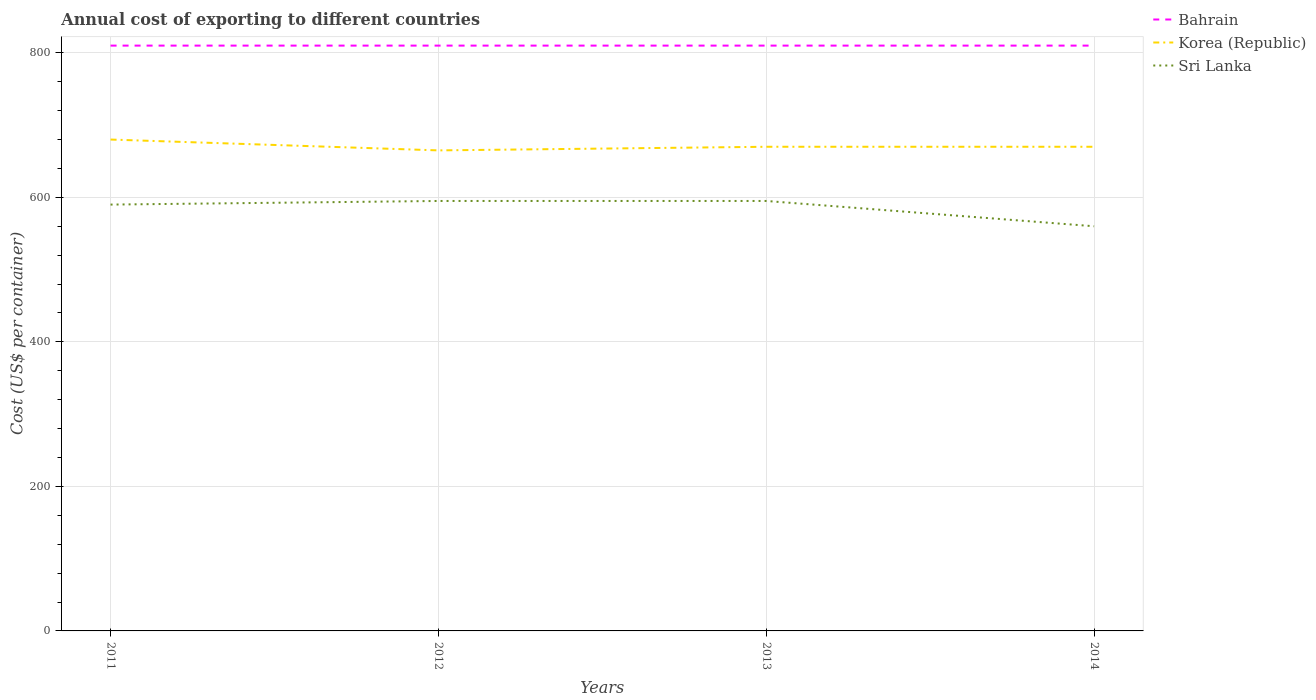Does the line corresponding to Bahrain intersect with the line corresponding to Sri Lanka?
Provide a short and direct response. No. Is the number of lines equal to the number of legend labels?
Offer a very short reply. Yes. Across all years, what is the maximum total annual cost of exporting in Sri Lanka?
Make the answer very short. 560. What is the total total annual cost of exporting in Bahrain in the graph?
Keep it short and to the point. 0. What is the difference between the highest and the second highest total annual cost of exporting in Bahrain?
Give a very brief answer. 0. How many lines are there?
Your answer should be very brief. 3. How many years are there in the graph?
Provide a succinct answer. 4. What is the difference between two consecutive major ticks on the Y-axis?
Provide a short and direct response. 200. Are the values on the major ticks of Y-axis written in scientific E-notation?
Your answer should be compact. No. Does the graph contain any zero values?
Offer a terse response. No. Where does the legend appear in the graph?
Your answer should be very brief. Top right. How are the legend labels stacked?
Make the answer very short. Vertical. What is the title of the graph?
Provide a succinct answer. Annual cost of exporting to different countries. What is the label or title of the X-axis?
Your answer should be very brief. Years. What is the label or title of the Y-axis?
Provide a short and direct response. Cost (US$ per container). What is the Cost (US$ per container) of Bahrain in 2011?
Your answer should be compact. 810. What is the Cost (US$ per container) of Korea (Republic) in 2011?
Provide a short and direct response. 680. What is the Cost (US$ per container) of Sri Lanka in 2011?
Ensure brevity in your answer.  590. What is the Cost (US$ per container) in Bahrain in 2012?
Offer a terse response. 810. What is the Cost (US$ per container) in Korea (Republic) in 2012?
Provide a short and direct response. 665. What is the Cost (US$ per container) in Sri Lanka in 2012?
Make the answer very short. 595. What is the Cost (US$ per container) in Bahrain in 2013?
Offer a terse response. 810. What is the Cost (US$ per container) of Korea (Republic) in 2013?
Offer a terse response. 670. What is the Cost (US$ per container) in Sri Lanka in 2013?
Keep it short and to the point. 595. What is the Cost (US$ per container) in Bahrain in 2014?
Give a very brief answer. 810. What is the Cost (US$ per container) in Korea (Republic) in 2014?
Provide a succinct answer. 670. What is the Cost (US$ per container) of Sri Lanka in 2014?
Offer a terse response. 560. Across all years, what is the maximum Cost (US$ per container) of Bahrain?
Make the answer very short. 810. Across all years, what is the maximum Cost (US$ per container) in Korea (Republic)?
Make the answer very short. 680. Across all years, what is the maximum Cost (US$ per container) of Sri Lanka?
Offer a very short reply. 595. Across all years, what is the minimum Cost (US$ per container) of Bahrain?
Your response must be concise. 810. Across all years, what is the minimum Cost (US$ per container) of Korea (Republic)?
Your answer should be very brief. 665. Across all years, what is the minimum Cost (US$ per container) of Sri Lanka?
Make the answer very short. 560. What is the total Cost (US$ per container) in Bahrain in the graph?
Ensure brevity in your answer.  3240. What is the total Cost (US$ per container) in Korea (Republic) in the graph?
Offer a terse response. 2685. What is the total Cost (US$ per container) in Sri Lanka in the graph?
Give a very brief answer. 2340. What is the difference between the Cost (US$ per container) in Bahrain in 2011 and that in 2012?
Offer a very short reply. 0. What is the difference between the Cost (US$ per container) in Bahrain in 2012 and that in 2013?
Offer a very short reply. 0. What is the difference between the Cost (US$ per container) of Korea (Republic) in 2012 and that in 2013?
Your response must be concise. -5. What is the difference between the Cost (US$ per container) of Sri Lanka in 2012 and that in 2013?
Provide a succinct answer. 0. What is the difference between the Cost (US$ per container) in Bahrain in 2012 and that in 2014?
Offer a terse response. 0. What is the difference between the Cost (US$ per container) of Korea (Republic) in 2012 and that in 2014?
Offer a terse response. -5. What is the difference between the Cost (US$ per container) in Bahrain in 2013 and that in 2014?
Keep it short and to the point. 0. What is the difference between the Cost (US$ per container) in Bahrain in 2011 and the Cost (US$ per container) in Korea (Republic) in 2012?
Ensure brevity in your answer.  145. What is the difference between the Cost (US$ per container) of Bahrain in 2011 and the Cost (US$ per container) of Sri Lanka in 2012?
Give a very brief answer. 215. What is the difference between the Cost (US$ per container) in Bahrain in 2011 and the Cost (US$ per container) in Korea (Republic) in 2013?
Your answer should be compact. 140. What is the difference between the Cost (US$ per container) of Bahrain in 2011 and the Cost (US$ per container) of Sri Lanka in 2013?
Keep it short and to the point. 215. What is the difference between the Cost (US$ per container) of Korea (Republic) in 2011 and the Cost (US$ per container) of Sri Lanka in 2013?
Your response must be concise. 85. What is the difference between the Cost (US$ per container) in Bahrain in 2011 and the Cost (US$ per container) in Korea (Republic) in 2014?
Keep it short and to the point. 140. What is the difference between the Cost (US$ per container) in Bahrain in 2011 and the Cost (US$ per container) in Sri Lanka in 2014?
Your answer should be very brief. 250. What is the difference between the Cost (US$ per container) of Korea (Republic) in 2011 and the Cost (US$ per container) of Sri Lanka in 2014?
Your response must be concise. 120. What is the difference between the Cost (US$ per container) in Bahrain in 2012 and the Cost (US$ per container) in Korea (Republic) in 2013?
Keep it short and to the point. 140. What is the difference between the Cost (US$ per container) in Bahrain in 2012 and the Cost (US$ per container) in Sri Lanka in 2013?
Make the answer very short. 215. What is the difference between the Cost (US$ per container) in Bahrain in 2012 and the Cost (US$ per container) in Korea (Republic) in 2014?
Your answer should be compact. 140. What is the difference between the Cost (US$ per container) of Bahrain in 2012 and the Cost (US$ per container) of Sri Lanka in 2014?
Your response must be concise. 250. What is the difference between the Cost (US$ per container) in Korea (Republic) in 2012 and the Cost (US$ per container) in Sri Lanka in 2014?
Your response must be concise. 105. What is the difference between the Cost (US$ per container) of Bahrain in 2013 and the Cost (US$ per container) of Korea (Republic) in 2014?
Offer a very short reply. 140. What is the difference between the Cost (US$ per container) in Bahrain in 2013 and the Cost (US$ per container) in Sri Lanka in 2014?
Offer a very short reply. 250. What is the difference between the Cost (US$ per container) of Korea (Republic) in 2013 and the Cost (US$ per container) of Sri Lanka in 2014?
Keep it short and to the point. 110. What is the average Cost (US$ per container) of Bahrain per year?
Give a very brief answer. 810. What is the average Cost (US$ per container) in Korea (Republic) per year?
Your answer should be compact. 671.25. What is the average Cost (US$ per container) in Sri Lanka per year?
Ensure brevity in your answer.  585. In the year 2011, what is the difference between the Cost (US$ per container) of Bahrain and Cost (US$ per container) of Korea (Republic)?
Give a very brief answer. 130. In the year 2011, what is the difference between the Cost (US$ per container) of Bahrain and Cost (US$ per container) of Sri Lanka?
Make the answer very short. 220. In the year 2012, what is the difference between the Cost (US$ per container) in Bahrain and Cost (US$ per container) in Korea (Republic)?
Keep it short and to the point. 145. In the year 2012, what is the difference between the Cost (US$ per container) in Bahrain and Cost (US$ per container) in Sri Lanka?
Offer a very short reply. 215. In the year 2013, what is the difference between the Cost (US$ per container) in Bahrain and Cost (US$ per container) in Korea (Republic)?
Ensure brevity in your answer.  140. In the year 2013, what is the difference between the Cost (US$ per container) of Bahrain and Cost (US$ per container) of Sri Lanka?
Offer a very short reply. 215. In the year 2014, what is the difference between the Cost (US$ per container) in Bahrain and Cost (US$ per container) in Korea (Republic)?
Make the answer very short. 140. In the year 2014, what is the difference between the Cost (US$ per container) of Bahrain and Cost (US$ per container) of Sri Lanka?
Provide a succinct answer. 250. In the year 2014, what is the difference between the Cost (US$ per container) in Korea (Republic) and Cost (US$ per container) in Sri Lanka?
Your answer should be very brief. 110. What is the ratio of the Cost (US$ per container) in Bahrain in 2011 to that in 2012?
Keep it short and to the point. 1. What is the ratio of the Cost (US$ per container) in Korea (Republic) in 2011 to that in 2012?
Your answer should be very brief. 1.02. What is the ratio of the Cost (US$ per container) in Korea (Republic) in 2011 to that in 2013?
Offer a very short reply. 1.01. What is the ratio of the Cost (US$ per container) of Sri Lanka in 2011 to that in 2013?
Offer a terse response. 0.99. What is the ratio of the Cost (US$ per container) in Korea (Republic) in 2011 to that in 2014?
Your response must be concise. 1.01. What is the ratio of the Cost (US$ per container) in Sri Lanka in 2011 to that in 2014?
Keep it short and to the point. 1.05. What is the ratio of the Cost (US$ per container) of Korea (Republic) in 2012 to that in 2013?
Your answer should be compact. 0.99. What is the ratio of the Cost (US$ per container) of Sri Lanka in 2012 to that in 2013?
Provide a short and direct response. 1. What is the ratio of the Cost (US$ per container) in Bahrain in 2012 to that in 2014?
Provide a short and direct response. 1. What is the ratio of the Cost (US$ per container) in Sri Lanka in 2012 to that in 2014?
Offer a terse response. 1.06. What is the ratio of the Cost (US$ per container) in Bahrain in 2013 to that in 2014?
Your answer should be compact. 1. What is the ratio of the Cost (US$ per container) in Sri Lanka in 2013 to that in 2014?
Provide a succinct answer. 1.06. What is the difference between the highest and the second highest Cost (US$ per container) in Bahrain?
Ensure brevity in your answer.  0. What is the difference between the highest and the lowest Cost (US$ per container) of Sri Lanka?
Give a very brief answer. 35. 